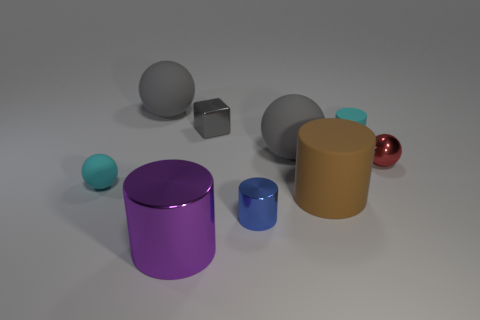What shape is the big object that is on the left side of the small blue metallic cylinder and behind the big metal thing?
Provide a short and direct response. Sphere. Is there a blue object of the same size as the purple metallic thing?
Your response must be concise. No. Do the big metallic cylinder and the big matte object left of the purple metal cylinder have the same color?
Your answer should be compact. No. What is the red ball made of?
Give a very brief answer. Metal. There is a small rubber thing on the right side of the purple thing; what color is it?
Your answer should be very brief. Cyan. What number of big rubber things have the same color as the tiny metallic block?
Your answer should be compact. 2. What number of tiny things are behind the tiny matte ball and left of the small shiny cylinder?
Your answer should be very brief. 1. The rubber thing that is the same size as the cyan cylinder is what shape?
Offer a very short reply. Sphere. How big is the red thing?
Offer a terse response. Small. The cyan thing to the right of the big matte ball that is right of the big gray rubber ball that is to the left of the small blue thing is made of what material?
Keep it short and to the point. Rubber. 